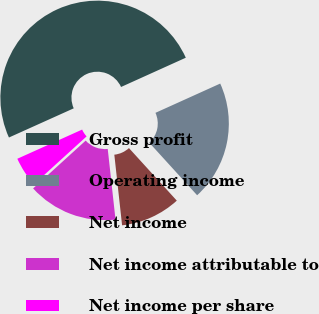Convert chart. <chart><loc_0><loc_0><loc_500><loc_500><pie_chart><fcel>Gross profit<fcel>Operating income<fcel>Net income<fcel>Net income attributable to<fcel>Net income per share<nl><fcel>49.98%<fcel>20.0%<fcel>10.01%<fcel>15.0%<fcel>5.01%<nl></chart> 